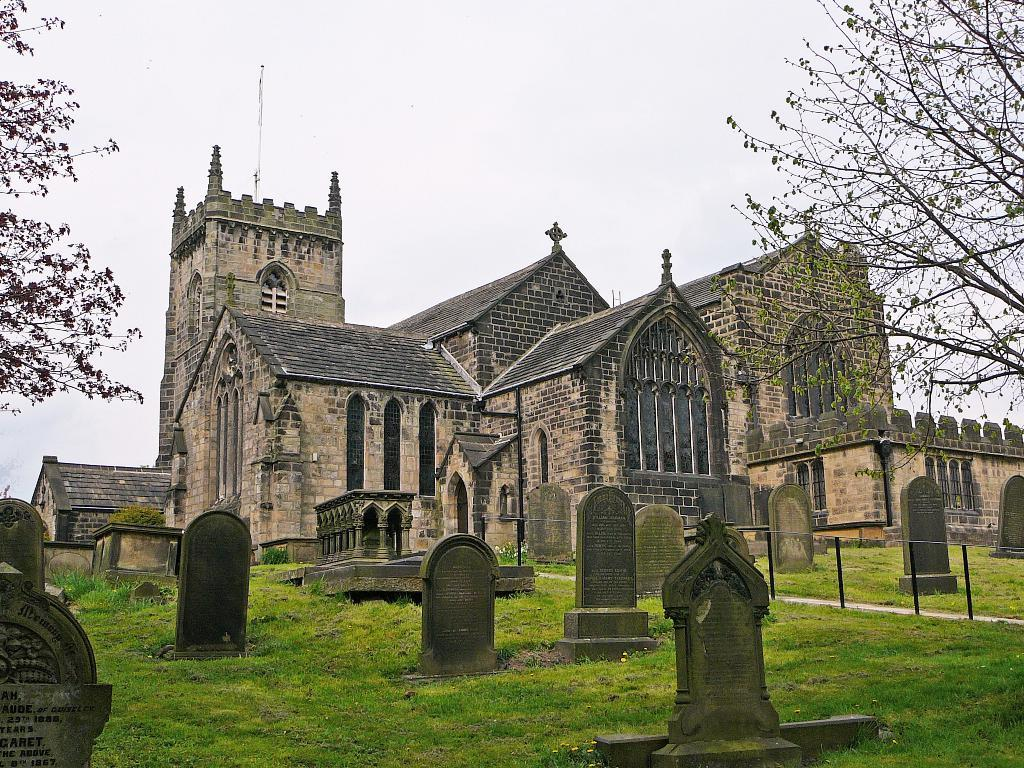What can be seen in the foreground of the picture? There are gravestones and trees in the foreground of the picture. What structure is located in the middle of the picture? There is a church in the middle of the picture. What is visible at the top of the picture? The sky is visible at the top of the picture. What material is present in the foreground of the picture? There is glass in the foreground of the picture. What word is written on the gravestones in the image? There is no specific word visible on the gravestones in the image; only the gravestones themselves are present. How does the stomach of the church appear in the image? The image does not depict a church with a stomach; it is a physical structure, not a living being. 